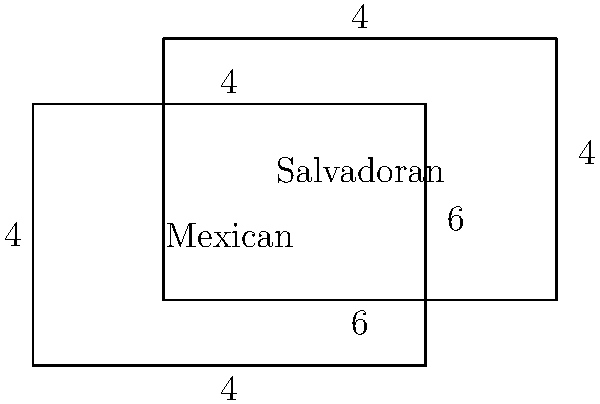Two immigrant communities, Mexican and Salvadoran, are represented by overlapping rectangles. The Mexican community's rectangle measures 6 units by 4 units, while the Salvadoran community's rectangle measures 6 units by 4 units and is shifted 2 units right and 1 unit up from the Mexican community's rectangle. What is the total area covered by both communities combined? To solve this problem, we need to follow these steps:

1. Calculate the area of the Mexican community's rectangle:
   $A_M = 6 \times 4 = 24$ square units

2. Calculate the area of the Salvadoran community's rectangle:
   $A_S = 6 \times 4 = 24$ square units

3. Calculate the area of the overlapping region:
   Width of overlap = $6 - 2 = 4$ units
   Height of overlap = $4 - 1 = 3$ units
   $A_O = 4 \times 3 = 12$ square units

4. Calculate the total area by adding the areas of both rectangles and subtracting the overlapping area:
   $A_T = A_M + A_S - A_O$
   $A_T = 24 + 24 - 12 = 36$ square units

Therefore, the total area covered by both communities combined is 36 square units.
Answer: 36 square units 